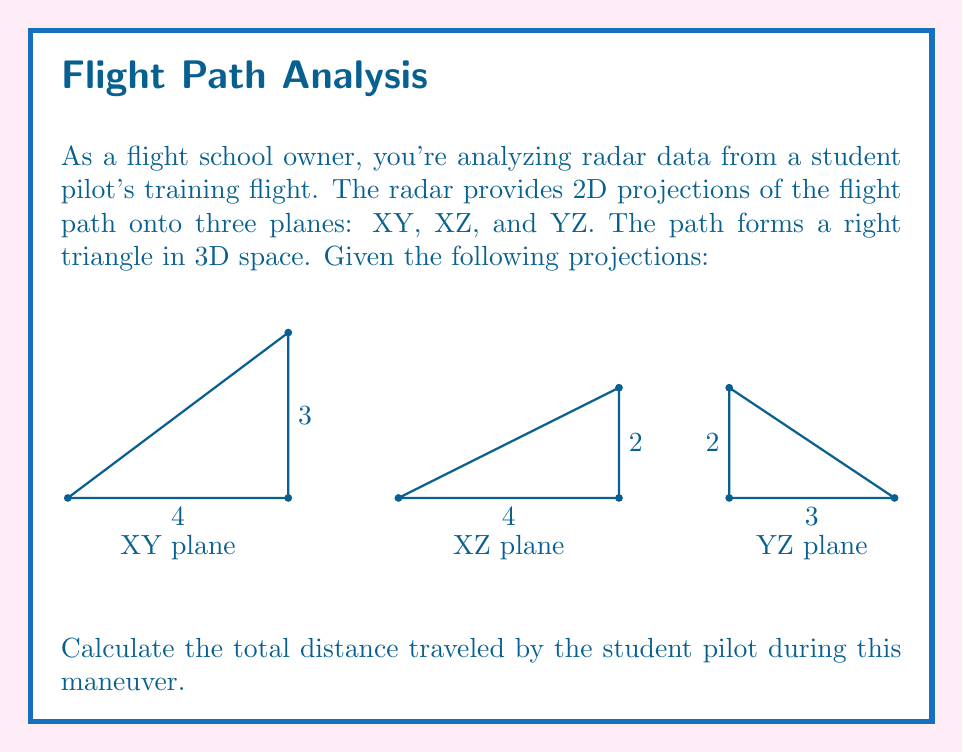Give your solution to this math problem. Let's approach this step-by-step:

1) The flight path forms a right triangle in 3D space. We need to find the length of the hypotenuse of this triangle.

2) From the XY projection, we can see that the base of the triangle is 4 units long and one side is 3 units long.

3) From the XZ projection, we can see that the height of the triangle is 2 units.

4) We can use the 3D version of the Pythagorean theorem to calculate the length of the hypotenuse:

   $$c^2 = a^2 + b^2 + h^2$$

   Where:
   $c$ is the length of the hypotenuse (our answer)
   $a$ is the length of the base (4)
   $b$ is the length of one side (3)
   $h$ is the height (2)

5) Substituting these values:

   $$c^2 = 4^2 + 3^2 + 2^2$$

6) Simplifying:

   $$c^2 = 16 + 9 + 4 = 29$$

7) Taking the square root of both sides:

   $$c = \sqrt{29}$$

8) This can be simplified to:

   $$c = \sqrt{29} \approx 5.385$$

Therefore, the total distance traveled is $\sqrt{29}$ units, or approximately 5.385 units.
Answer: $\sqrt{29}$ units 